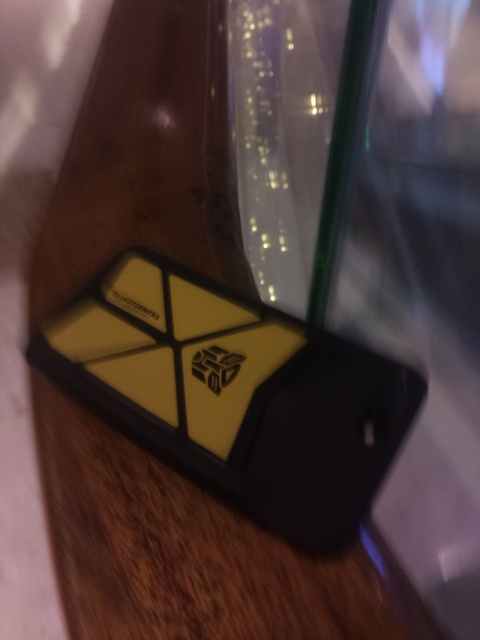What could the blurred backdrop in the image be? It's difficult to ascertain details due to the blur, but it resembles a lighted, bokeh effect typical in photos taken with a focus on a nearby object, thus making the distant background elements merge into soft orbs of light. 